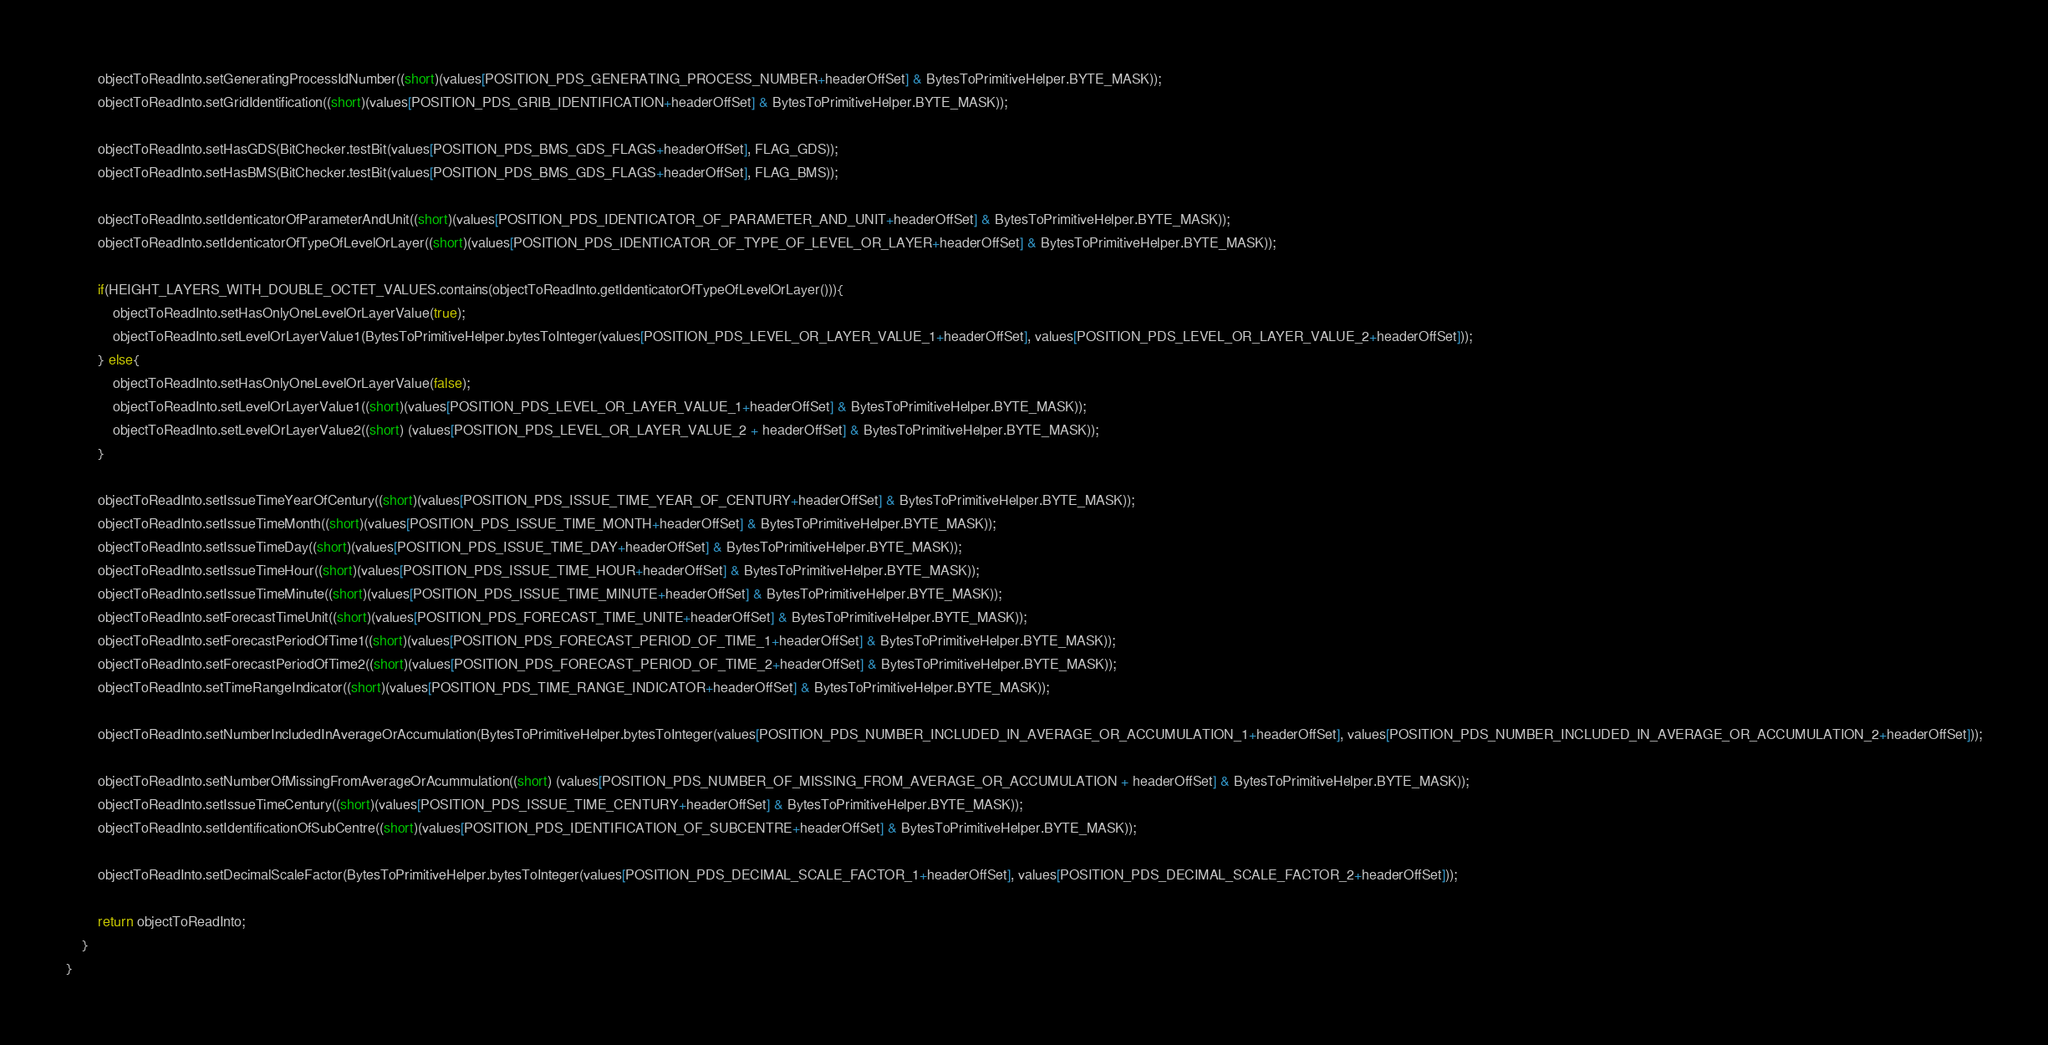Convert code to text. <code><loc_0><loc_0><loc_500><loc_500><_Java_>        objectToReadInto.setGeneratingProcessIdNumber((short)(values[POSITION_PDS_GENERATING_PROCESS_NUMBER+headerOffSet] & BytesToPrimitiveHelper.BYTE_MASK));
        objectToReadInto.setGridIdentification((short)(values[POSITION_PDS_GRIB_IDENTIFICATION+headerOffSet] & BytesToPrimitiveHelper.BYTE_MASK));

        objectToReadInto.setHasGDS(BitChecker.testBit(values[POSITION_PDS_BMS_GDS_FLAGS+headerOffSet], FLAG_GDS));
        objectToReadInto.setHasBMS(BitChecker.testBit(values[POSITION_PDS_BMS_GDS_FLAGS+headerOffSet], FLAG_BMS));

        objectToReadInto.setIdenticatorOfParameterAndUnit((short)(values[POSITION_PDS_IDENTICATOR_OF_PARAMETER_AND_UNIT+headerOffSet] & BytesToPrimitiveHelper.BYTE_MASK));
        objectToReadInto.setIdenticatorOfTypeOfLevelOrLayer((short)(values[POSITION_PDS_IDENTICATOR_OF_TYPE_OF_LEVEL_OR_LAYER+headerOffSet] & BytesToPrimitiveHelper.BYTE_MASK));

        if(HEIGHT_LAYERS_WITH_DOUBLE_OCTET_VALUES.contains(objectToReadInto.getIdenticatorOfTypeOfLevelOrLayer())){
            objectToReadInto.setHasOnlyOneLevelOrLayerValue(true);
            objectToReadInto.setLevelOrLayerValue1(BytesToPrimitiveHelper.bytesToInteger(values[POSITION_PDS_LEVEL_OR_LAYER_VALUE_1+headerOffSet], values[POSITION_PDS_LEVEL_OR_LAYER_VALUE_2+headerOffSet]));
        } else{
            objectToReadInto.setHasOnlyOneLevelOrLayerValue(false);
            objectToReadInto.setLevelOrLayerValue1((short)(values[POSITION_PDS_LEVEL_OR_LAYER_VALUE_1+headerOffSet] & BytesToPrimitiveHelper.BYTE_MASK));
            objectToReadInto.setLevelOrLayerValue2((short) (values[POSITION_PDS_LEVEL_OR_LAYER_VALUE_2 + headerOffSet] & BytesToPrimitiveHelper.BYTE_MASK));
        }

        objectToReadInto.setIssueTimeYearOfCentury((short)(values[POSITION_PDS_ISSUE_TIME_YEAR_OF_CENTURY+headerOffSet] & BytesToPrimitiveHelper.BYTE_MASK));
        objectToReadInto.setIssueTimeMonth((short)(values[POSITION_PDS_ISSUE_TIME_MONTH+headerOffSet] & BytesToPrimitiveHelper.BYTE_MASK));
        objectToReadInto.setIssueTimeDay((short)(values[POSITION_PDS_ISSUE_TIME_DAY+headerOffSet] & BytesToPrimitiveHelper.BYTE_MASK));
        objectToReadInto.setIssueTimeHour((short)(values[POSITION_PDS_ISSUE_TIME_HOUR+headerOffSet] & BytesToPrimitiveHelper.BYTE_MASK));
        objectToReadInto.setIssueTimeMinute((short)(values[POSITION_PDS_ISSUE_TIME_MINUTE+headerOffSet] & BytesToPrimitiveHelper.BYTE_MASK));
        objectToReadInto.setForecastTimeUnit((short)(values[POSITION_PDS_FORECAST_TIME_UNITE+headerOffSet] & BytesToPrimitiveHelper.BYTE_MASK));
        objectToReadInto.setForecastPeriodOfTime1((short)(values[POSITION_PDS_FORECAST_PERIOD_OF_TIME_1+headerOffSet] & BytesToPrimitiveHelper.BYTE_MASK));
        objectToReadInto.setForecastPeriodOfTime2((short)(values[POSITION_PDS_FORECAST_PERIOD_OF_TIME_2+headerOffSet] & BytesToPrimitiveHelper.BYTE_MASK));
        objectToReadInto.setTimeRangeIndicator((short)(values[POSITION_PDS_TIME_RANGE_INDICATOR+headerOffSet] & BytesToPrimitiveHelper.BYTE_MASK));

        objectToReadInto.setNumberIncludedInAverageOrAccumulation(BytesToPrimitiveHelper.bytesToInteger(values[POSITION_PDS_NUMBER_INCLUDED_IN_AVERAGE_OR_ACCUMULATION_1+headerOffSet], values[POSITION_PDS_NUMBER_INCLUDED_IN_AVERAGE_OR_ACCUMULATION_2+headerOffSet]));

        objectToReadInto.setNumberOfMissingFromAverageOrAcummulation((short) (values[POSITION_PDS_NUMBER_OF_MISSING_FROM_AVERAGE_OR_ACCUMULATION + headerOffSet] & BytesToPrimitiveHelper.BYTE_MASK));
        objectToReadInto.setIssueTimeCentury((short)(values[POSITION_PDS_ISSUE_TIME_CENTURY+headerOffSet] & BytesToPrimitiveHelper.BYTE_MASK));
        objectToReadInto.setIdentificationOfSubCentre((short)(values[POSITION_PDS_IDENTIFICATION_OF_SUBCENTRE+headerOffSet] & BytesToPrimitiveHelper.BYTE_MASK));

        objectToReadInto.setDecimalScaleFactor(BytesToPrimitiveHelper.bytesToInteger(values[POSITION_PDS_DECIMAL_SCALE_FACTOR_1+headerOffSet], values[POSITION_PDS_DECIMAL_SCALE_FACTOR_2+headerOffSet]));

        return objectToReadInto;
    }
}
</code> 